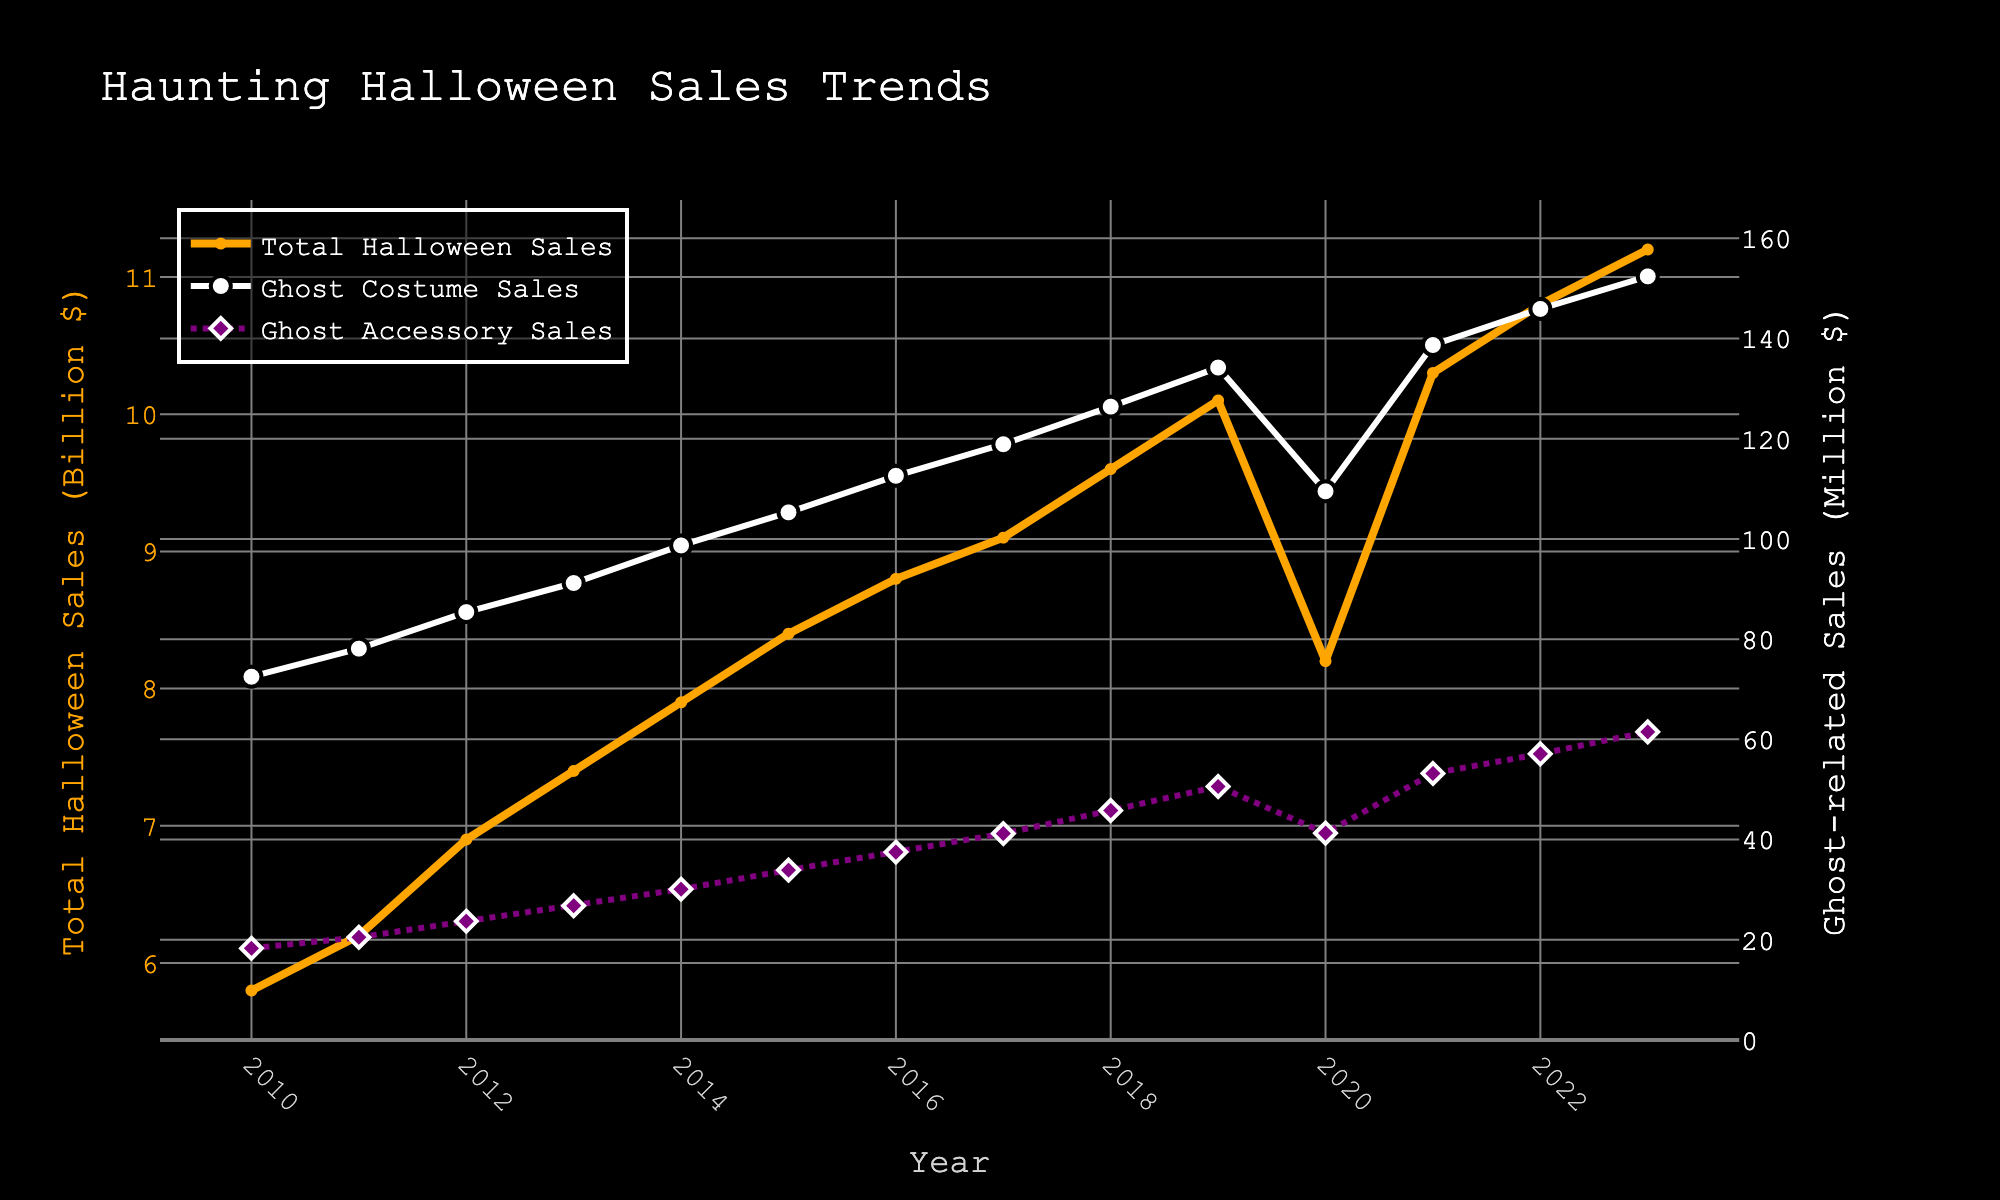How have total Halloween sales and ghost costume sales trends differed? To see the trends, observe the orange line for total Halloween sales and the white line for ghost costume sales. Both generally increase over the years, but total Halloween sales show a slight dip around 2020 while ghost costume sales also dip but recover sharply soon after.
Answer: Trends are similar with dips in 2020, but ghost costume sales recover faster What was the difference in Ghost Costume Sales between 2022 and 2023? To find the difference, look at the values of ghost costume sales in 2022 and 2023. In 2022 it's $145.9M, and in 2023 it's $152.4M. The difference is $152.4M - $145.9M.
Answer: $6.5M Which year had the highest total Halloween sales, and what was the amount? Look at the highest peak of the orange line on the plot for total Halloween sales. This occurs in 2023, indicating that year had the highest sales.
Answer: 2023, $11.2B By how much did ghost accessory sales increase from 2010 to 2023? Compare the values for ghost accessory sales in 2010 ($18.3M) and in 2023 ($61.5M). The increase is $61.5M - $18.3M.
Answer: $43.2M What was the trend in ghost costume sales immediately following the dip in 2020? To see the trend, look at the white line representing ghost costume sales around 2020. After the dip, the sales increase steadily in 2021, 2022, and 2023.
Answer: Increased steadily Which sales category had a more significant dip in 2020, and what were the values before and during the dip? Compare the values for total Halloween sales and ghost costume sales in 2019 and 2020. Total Halloween sales went from $10.1B in 2019 to $8.2B in 2020, and ghost costume sales went from $134.2M in 2019 to $109.5M in 2020.
Answer: Total Halloween Sales: $10.1B to $8.2B What is the average annual increase in ghost costume sales from 2010 to 2019? First, find the total increase in ghost costume sales from 2010 ($72.5M) to 2019 ($134.2M) which is $134.2M - $72.5M = $61.7M. Divide this by the number of years (2019 - 2010 = 9 years).
Answer: Approximately $6.86M per year 